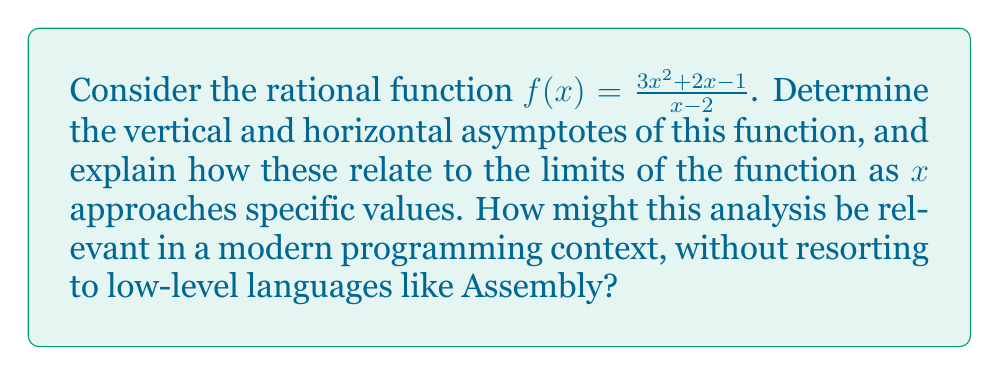Can you solve this math problem? Let's approach this step-by-step:

1) Vertical asymptote:
   The vertical asymptote occurs where the denominator equals zero.
   $x - 2 = 0$
   $x = 2$

2) Horizontal asymptote:
   To find the horizontal asymptote, we compare the degrees of the numerator and denominator:
   Degree of numerator = 2
   Degree of denominator = 1
   Since the degree of the numerator is greater, we divide:
   
   $$\lim_{x \to \infty} \frac{3x^2 + 2x - 1}{x - 2} = \lim_{x \to \infty} (3x + 8 + \frac{17}{x-2})$$
   
   The horizontal asymptote is $y = 3x + 8$.

3) Limits:
   a) $\lim_{x \to 2^-} f(x) = -\infty$
   b) $\lim_{x \to 2^+} f(x) = +\infty$
   c) $\lim_{x \to \infty} f(x) = +\infty$
   d) $\lim_{x \to -\infty} f(x) = -\infty$

These limits directly relate to the asymptotes we found. The vertical asymptote at $x = 2$ is reflected in the limits as $x$ approaches 2 from both sides. The slant asymptote $y = 3x + 8$ is reflected in the behavior of the function as $x$ approaches infinity.

In a modern programming context, understanding these concepts is crucial for numerical analysis, computer graphics, and data visualization. High-level languages and libraries can efficiently handle these calculations without needing Assembly language. For instance, Python's NumPy and Matplotlib libraries can be used to compute and visualize these limits and asymptotes, demonstrating that complex mathematical concepts can be implemented using modern, high-level programming tools.
Answer: Vertical asymptote: $x = 2$; Horizontal asymptote: None; Slant asymptote: $y = 3x + 8$ 